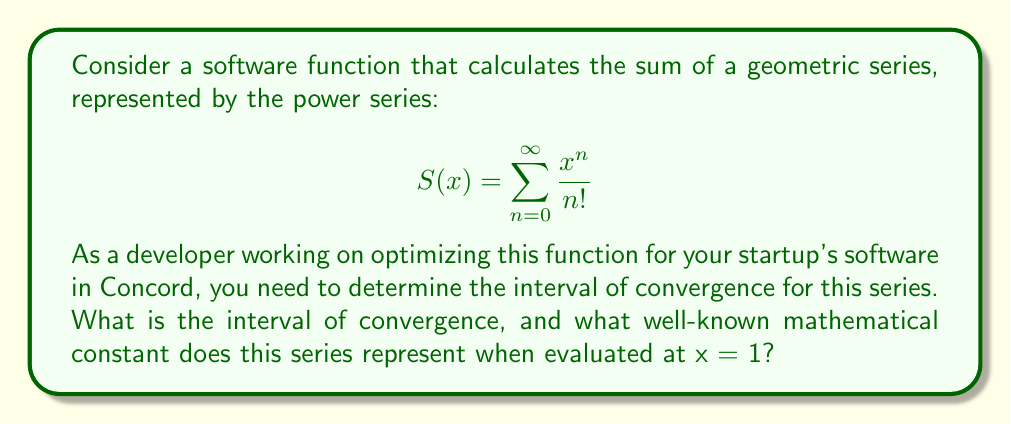Show me your answer to this math problem. Let's approach this step-by-step:

1) First, we need to determine the radius of convergence for this power series. We can use the ratio test:

   $$\lim_{n \to \infty} \left|\frac{a_{n+1}}{a_n}\right| = \lim_{n \to \infty} \left|\frac{\frac{x^{n+1}}{(n+1)!}}{\frac{x^n}{n!}}\right| = \lim_{n \to \infty} \left|\frac{x}{n+1}\right| = 0$$

   This limit is 0 for any finite value of x, which means the radius of convergence is infinite.

2) Since the radius of convergence is infinite, the interval of convergence is all real numbers: $(-\infty, \infty)$

3) Now, let's consider what this series represents when x = 1:

   $$S(1) = \sum_{n=0}^{\infty} \frac{1^n}{n!} = 1 + \frac{1}{1!} + \frac{1}{2!} + \frac{1}{3!} + ...$$

4) This is the Taylor series expansion of $e^x$ evaluated at x = 1, which equals e, the base of natural logarithms.

5) In software development, this series (known as the exponential series) is often used in various algorithms, including those related to growth modeling, compound interest calculations, and certain optimization problems.
Answer: Interval of convergence: $(-\infty, \infty)$; When x = 1, series equals e 